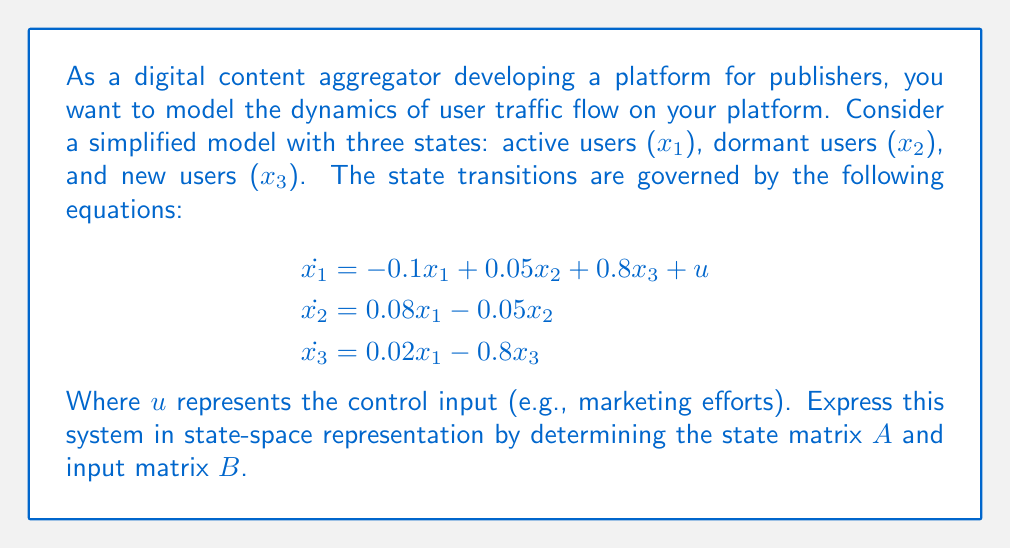Show me your answer to this math problem. To express the system in state-space representation, we need to identify the state matrix $A$ and input matrix $B$ in the general form:

$$\dot{x} = Ax + Bu$$

Where $x$ is the state vector $[x_1, x_2, x_3]^T$.

1. First, let's identify the coefficients for each state variable in the equations:

   For $\dot{x_1}$: 
   - Coefficient of $x_1$ is -0.1
   - Coefficient of $x_2$ is 0.05
   - Coefficient of $x_3$ is 0.8

   For $\dot{x_2}$:
   - Coefficient of $x_1$ is 0.08
   - Coefficient of $x_2$ is -0.05
   - Coefficient of $x_3$ is 0

   For $\dot{x_3}$:
   - Coefficient of $x_1$ is 0.02
   - Coefficient of $x_2$ is 0
   - Coefficient of $x_3$ is -0.8

2. Now, we can form the state matrix $A$ using these coefficients:

   $$A = \begin{bmatrix}
   -0.1 & 0.05 & 0.8 \\
   0.08 & -0.05 & 0 \\
   0.02 & 0 & -0.8
   \end{bmatrix}$$

3. For the input matrix $B$, we need to identify the coefficients of the control input $u$ in each equation:
   - In $\dot{x_1}$, the coefficient of $u$ is 1
   - In $\dot{x_2}$ and $\dot{x_3}$, there is no $u$ term, so the coefficients are 0

   Therefore, the input matrix $B$ is:

   $$B = \begin{bmatrix}
   1 \\
   0 \\
   0
   \end{bmatrix}$$

4. The complete state-space representation is:

   $$\dot{x} = Ax + Bu$$

   Where:
   
   $$A = \begin{bmatrix}
   -0.1 & 0.05 & 0.8 \\
   0.08 & -0.05 & 0 \\
   0.02 & 0 & -0.8
   \end{bmatrix}$$

   $$B = \begin{bmatrix}
   1 \\
   0 \\
   0
   \end{bmatrix}$$
Answer: The state-space representation of the system is:

$$\dot{x} = Ax + Bu$$

Where:

$$A = \begin{bmatrix}
-0.1 & 0.05 & 0.8 \\
0.08 & -0.05 & 0 \\
0.02 & 0 & -0.8
\end{bmatrix}$$

$$B = \begin{bmatrix}
1 \\
0 \\
0
\end{bmatrix}$$ 